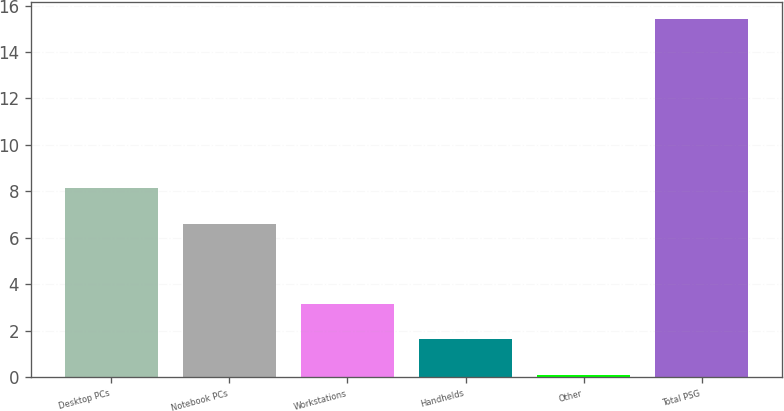Convert chart to OTSL. <chart><loc_0><loc_0><loc_500><loc_500><bar_chart><fcel>Desktop PCs<fcel>Notebook PCs<fcel>Workstations<fcel>Handhelds<fcel>Other<fcel>Total PSG<nl><fcel>8.13<fcel>6.6<fcel>3.16<fcel>1.63<fcel>0.1<fcel>15.4<nl></chart> 